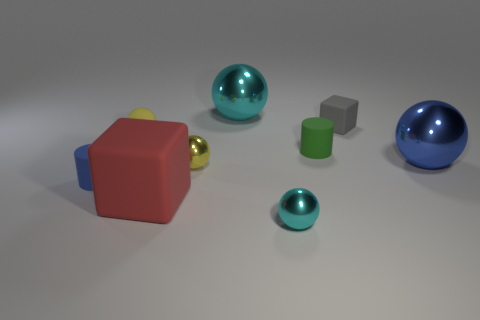Subtract all yellow spheres. How many were subtracted if there are1yellow spheres left? 1 Subtract all large balls. How many balls are left? 3 Add 1 big cyan things. How many big cyan things exist? 2 Add 1 cyan balls. How many objects exist? 10 Subtract all blue spheres. How many spheres are left? 4 Subtract 0 brown cylinders. How many objects are left? 9 Subtract all blocks. How many objects are left? 7 Subtract 1 balls. How many balls are left? 4 Subtract all red cubes. Subtract all yellow balls. How many cubes are left? 1 Subtract all yellow cylinders. How many gray blocks are left? 1 